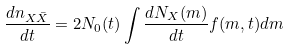Convert formula to latex. <formula><loc_0><loc_0><loc_500><loc_500>\frac { d n _ { X \bar { X } } } { d t } = 2 N _ { 0 } ( t ) \int \frac { d N _ { X } ( m ) } { d t } f ( m , t ) d m</formula> 